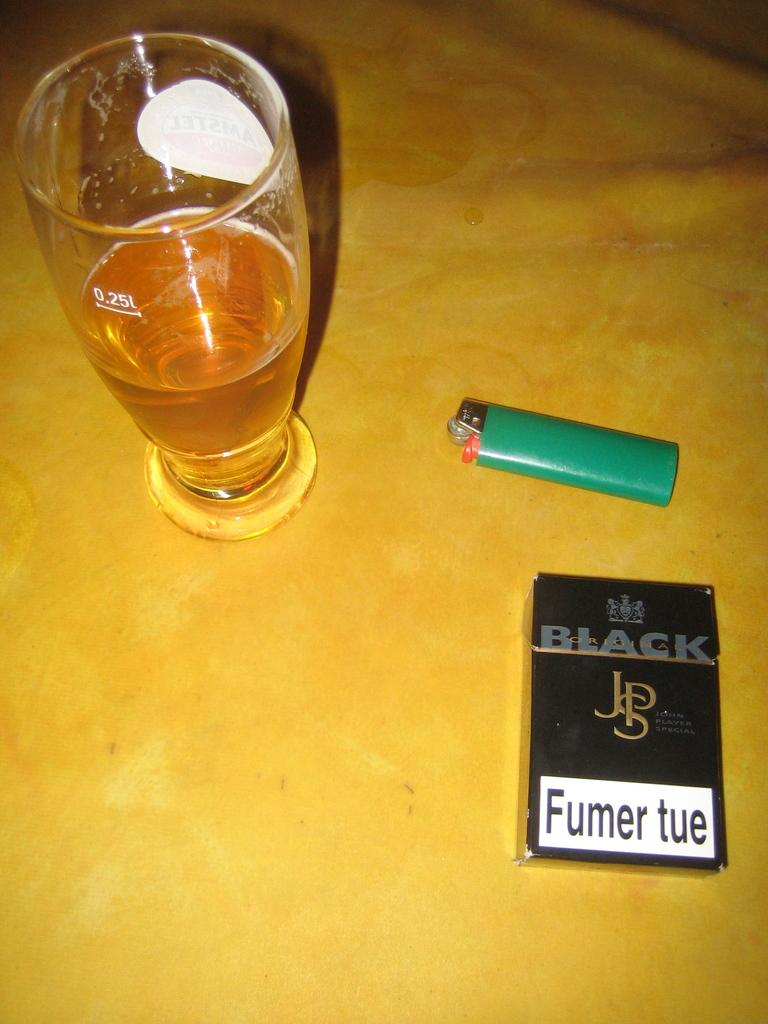<image>
Describe the image concisely. A black box with the initials JSP says the phrase "fumer tue" on it. 